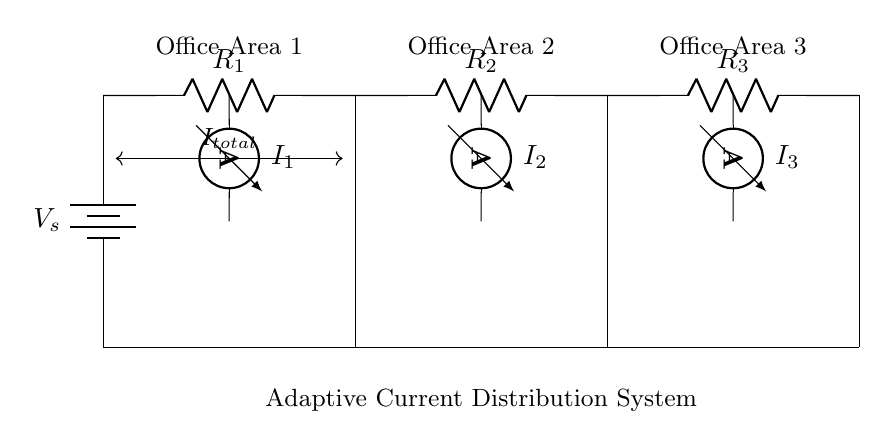What is the total current in the circuit? The total current is denoted as I_total, which represents the sum of the currents flowing into the office areas, shown near the battery and circuit connections.
Answer: I_total What are the resistances in the circuit? The resistances are R1, R2, and R3, which are labeled on the circuit diagram indicating the components that limit current flow in each section of the circuit.
Answer: R1, R2, R3 Which office area has the highest current? The current through each office area is denoted by I1, I2, and I3 at their respective ammeter locations, and without specific values given, we cannot determine which is the highest just by visual inspection.
Answer: I1, I2, or I3 (depends on values) What is the function of the ammeters in the circuit? The ammeters I1, I2, and I3 measure the current flowing through each office area, allowing the monitoring of adaptive current distribution as power needs vary.
Answer: Measure current How does the current divider function in different office areas? The current divider distributes the total current into branches based on the resistances of the resistors. The lower the resistance in a branch, the more current it receives relative to others. This distribution can adapt to changing power needs by altering the resistance values dynamically.
Answer: Distributes current based on resistance What does the title "Adaptive Current Distribution System" imply about this circuit? The title implies that the circuit is designed to adjust how current is allocated among the different office areas based on varying power requirements, making it responsive to real-time energy consumption needs.
Answer: Adjusts current allocation How can adjustments in resistance impact office area performance? Adjustments in resistance can change the amount of current passing through each office area, which directly affects the performance of devices connected in those areas. This could lead to better energy efficiency or ensure that critical devices receive sufficient power.
Answer: Impacts current flow 